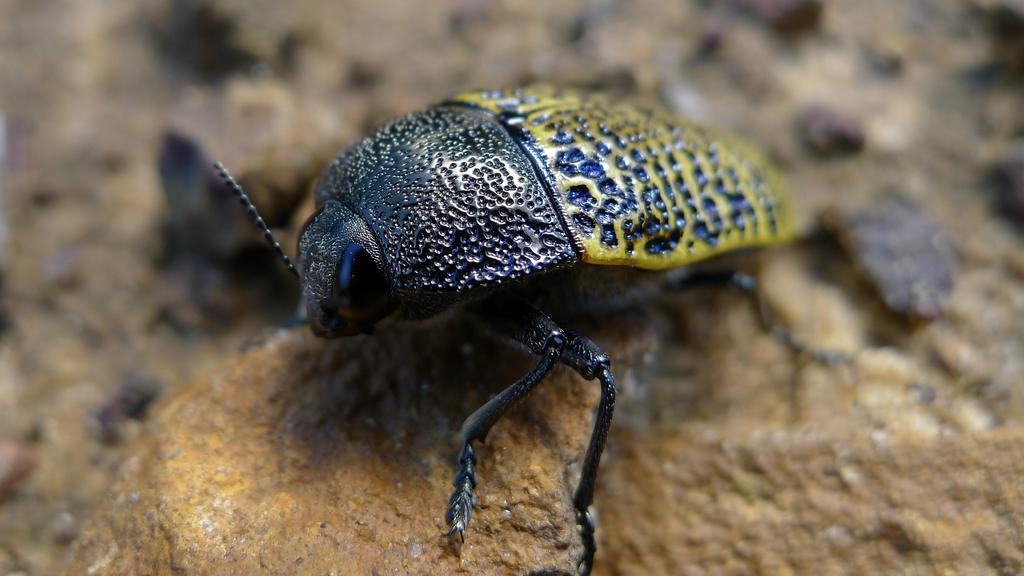What type of creature is in the image? There is an insect in the image. Where is the insect located? The insect is on a rock. Can you describe the background of the image? The background of the image is blurred. Where is the faucet located in the image? There is no faucet present in the image. What type of glove is the insect wearing in the image? There is no glove present in the image, and insects do not wear gloves. 